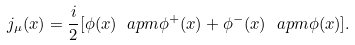Convert formula to latex. <formula><loc_0><loc_0><loc_500><loc_500>j _ { \mu } ( x ) = \frac { i } { 2 } [ \phi ( x ) \ a p m \phi ^ { + } ( x ) + \phi ^ { - } ( x ) \ a p m \phi ( x ) ] .</formula> 